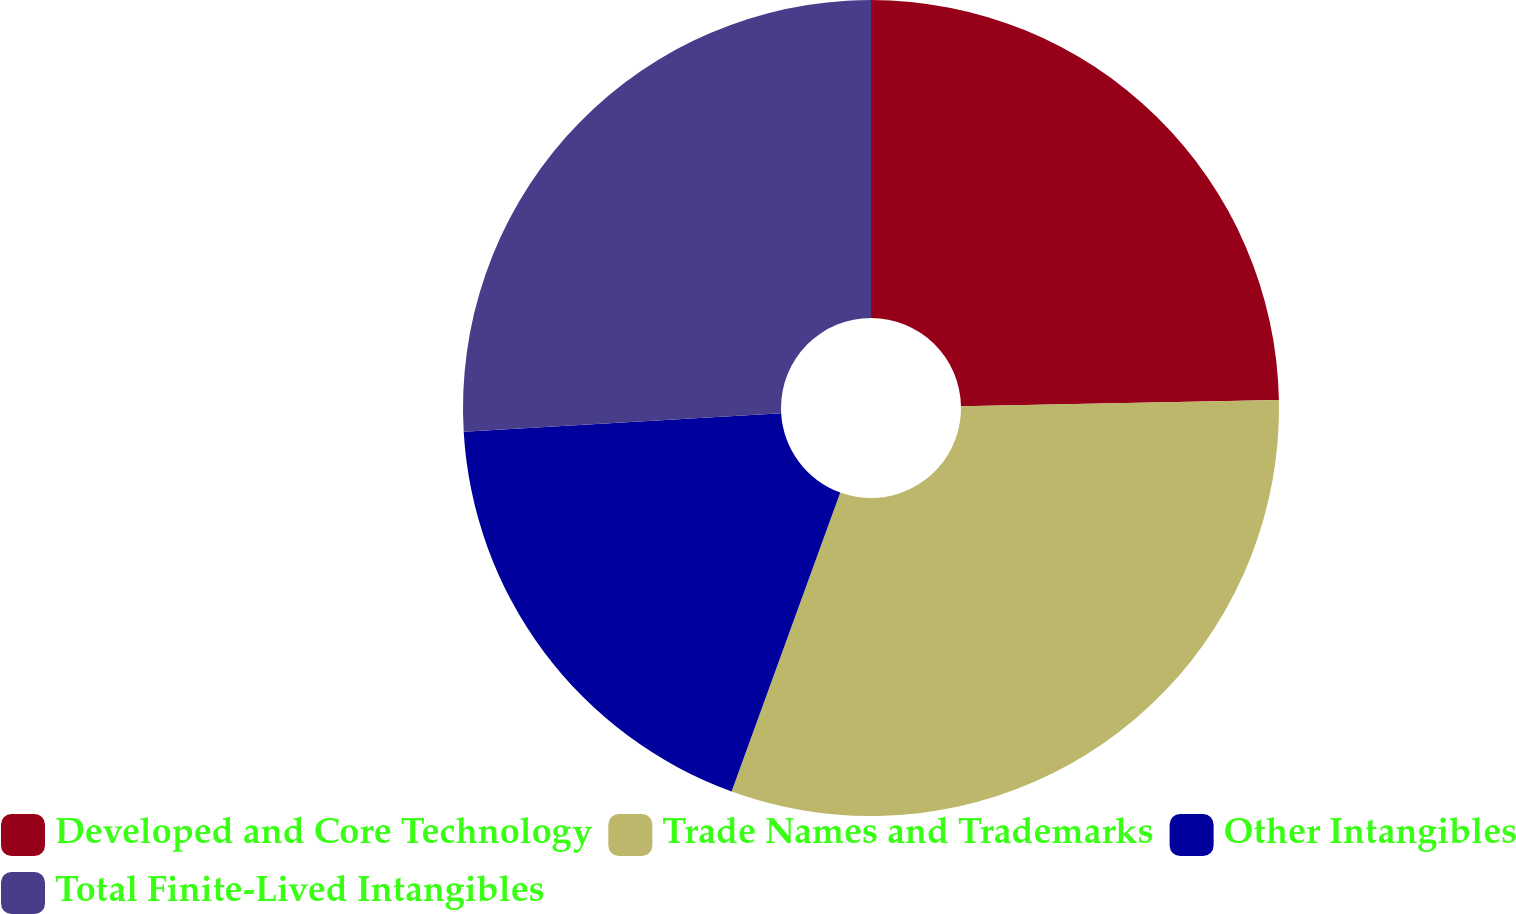<chart> <loc_0><loc_0><loc_500><loc_500><pie_chart><fcel>Developed and Core Technology<fcel>Trade Names and Trademarks<fcel>Other Intangibles<fcel>Total Finite-Lived Intangibles<nl><fcel>24.69%<fcel>30.86%<fcel>18.52%<fcel>25.93%<nl></chart> 